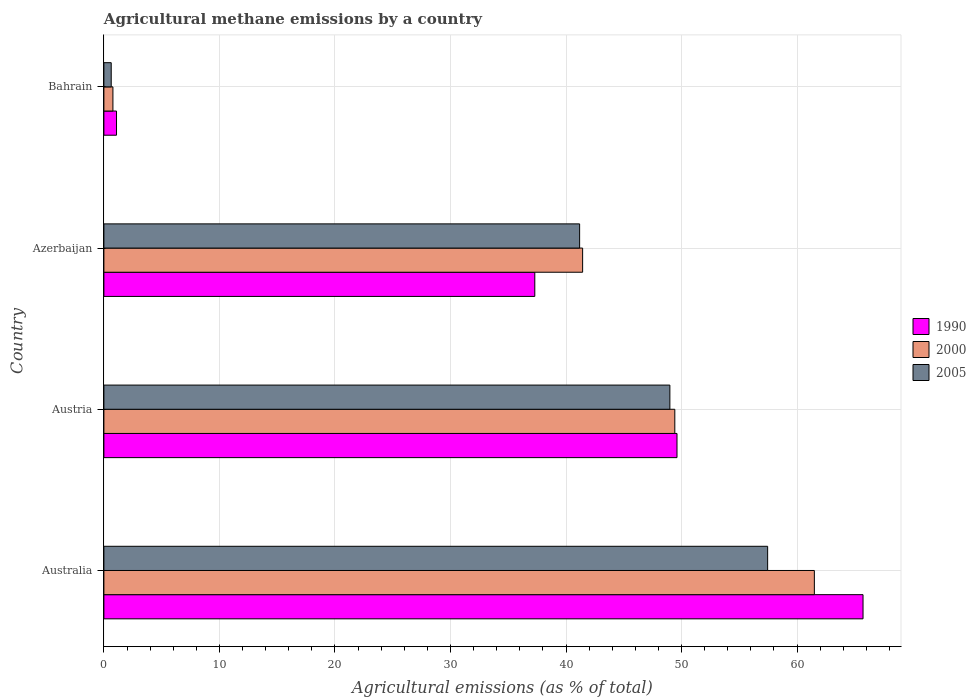How many different coloured bars are there?
Offer a terse response. 3. How many bars are there on the 4th tick from the top?
Your answer should be compact. 3. How many bars are there on the 1st tick from the bottom?
Give a very brief answer. 3. What is the label of the 2nd group of bars from the top?
Ensure brevity in your answer.  Azerbaijan. What is the amount of agricultural methane emitted in 2000 in Australia?
Offer a very short reply. 61.5. Across all countries, what is the maximum amount of agricultural methane emitted in 1990?
Offer a terse response. 65.71. Across all countries, what is the minimum amount of agricultural methane emitted in 1990?
Your answer should be very brief. 1.09. In which country was the amount of agricultural methane emitted in 1990 maximum?
Provide a short and direct response. Australia. In which country was the amount of agricultural methane emitted in 2000 minimum?
Give a very brief answer. Bahrain. What is the total amount of agricultural methane emitted in 2000 in the graph?
Give a very brief answer. 153.13. What is the difference between the amount of agricultural methane emitted in 2000 in Austria and that in Azerbaijan?
Your response must be concise. 7.98. What is the difference between the amount of agricultural methane emitted in 2000 in Bahrain and the amount of agricultural methane emitted in 2005 in Australia?
Your response must be concise. -56.67. What is the average amount of agricultural methane emitted in 2005 per country?
Offer a very short reply. 37.06. What is the difference between the amount of agricultural methane emitted in 2000 and amount of agricultural methane emitted in 1990 in Australia?
Ensure brevity in your answer.  -4.21. In how many countries, is the amount of agricultural methane emitted in 2005 greater than 26 %?
Offer a very short reply. 3. What is the ratio of the amount of agricultural methane emitted in 2000 in Austria to that in Azerbaijan?
Provide a short and direct response. 1.19. Is the difference between the amount of agricultural methane emitted in 2000 in Australia and Azerbaijan greater than the difference between the amount of agricultural methane emitted in 1990 in Australia and Azerbaijan?
Give a very brief answer. No. What is the difference between the highest and the second highest amount of agricultural methane emitted in 2000?
Your response must be concise. 12.08. What is the difference between the highest and the lowest amount of agricultural methane emitted in 1990?
Offer a terse response. 64.62. In how many countries, is the amount of agricultural methane emitted in 1990 greater than the average amount of agricultural methane emitted in 1990 taken over all countries?
Your answer should be very brief. 2. What does the 3rd bar from the bottom in Azerbaijan represents?
Make the answer very short. 2005. How many bars are there?
Offer a terse response. 12. Are all the bars in the graph horizontal?
Your answer should be very brief. Yes. What is the difference between two consecutive major ticks on the X-axis?
Offer a very short reply. 10. Are the values on the major ticks of X-axis written in scientific E-notation?
Provide a short and direct response. No. How many legend labels are there?
Ensure brevity in your answer.  3. How are the legend labels stacked?
Provide a short and direct response. Vertical. What is the title of the graph?
Offer a very short reply. Agricultural methane emissions by a country. What is the label or title of the X-axis?
Provide a short and direct response. Agricultural emissions (as % of total). What is the label or title of the Y-axis?
Give a very brief answer. Country. What is the Agricultural emissions (as % of total) of 1990 in Australia?
Give a very brief answer. 65.71. What is the Agricultural emissions (as % of total) in 2000 in Australia?
Provide a short and direct response. 61.5. What is the Agricultural emissions (as % of total) of 2005 in Australia?
Your answer should be compact. 57.45. What is the Agricultural emissions (as % of total) in 1990 in Austria?
Offer a terse response. 49.61. What is the Agricultural emissions (as % of total) in 2000 in Austria?
Your answer should be compact. 49.42. What is the Agricultural emissions (as % of total) in 2005 in Austria?
Give a very brief answer. 48.99. What is the Agricultural emissions (as % of total) in 1990 in Azerbaijan?
Your response must be concise. 37.3. What is the Agricultural emissions (as % of total) in 2000 in Azerbaijan?
Keep it short and to the point. 41.44. What is the Agricultural emissions (as % of total) of 2005 in Azerbaijan?
Offer a terse response. 41.18. What is the Agricultural emissions (as % of total) in 1990 in Bahrain?
Ensure brevity in your answer.  1.09. What is the Agricultural emissions (as % of total) of 2000 in Bahrain?
Give a very brief answer. 0.78. What is the Agricultural emissions (as % of total) of 2005 in Bahrain?
Your answer should be compact. 0.63. Across all countries, what is the maximum Agricultural emissions (as % of total) of 1990?
Provide a succinct answer. 65.71. Across all countries, what is the maximum Agricultural emissions (as % of total) of 2000?
Provide a succinct answer. 61.5. Across all countries, what is the maximum Agricultural emissions (as % of total) of 2005?
Make the answer very short. 57.45. Across all countries, what is the minimum Agricultural emissions (as % of total) of 1990?
Ensure brevity in your answer.  1.09. Across all countries, what is the minimum Agricultural emissions (as % of total) in 2000?
Your answer should be very brief. 0.78. Across all countries, what is the minimum Agricultural emissions (as % of total) of 2005?
Give a very brief answer. 0.63. What is the total Agricultural emissions (as % of total) of 1990 in the graph?
Make the answer very short. 153.71. What is the total Agricultural emissions (as % of total) in 2000 in the graph?
Provide a short and direct response. 153.13. What is the total Agricultural emissions (as % of total) in 2005 in the graph?
Provide a succinct answer. 148.25. What is the difference between the Agricultural emissions (as % of total) in 1990 in Australia and that in Austria?
Provide a short and direct response. 16.1. What is the difference between the Agricultural emissions (as % of total) in 2000 in Australia and that in Austria?
Ensure brevity in your answer.  12.08. What is the difference between the Agricultural emissions (as % of total) of 2005 in Australia and that in Austria?
Your answer should be very brief. 8.46. What is the difference between the Agricultural emissions (as % of total) in 1990 in Australia and that in Azerbaijan?
Keep it short and to the point. 28.41. What is the difference between the Agricultural emissions (as % of total) in 2000 in Australia and that in Azerbaijan?
Offer a very short reply. 20.06. What is the difference between the Agricultural emissions (as % of total) of 2005 in Australia and that in Azerbaijan?
Offer a terse response. 16.27. What is the difference between the Agricultural emissions (as % of total) in 1990 in Australia and that in Bahrain?
Offer a terse response. 64.62. What is the difference between the Agricultural emissions (as % of total) in 2000 in Australia and that in Bahrain?
Provide a short and direct response. 60.72. What is the difference between the Agricultural emissions (as % of total) in 2005 in Australia and that in Bahrain?
Your answer should be very brief. 56.82. What is the difference between the Agricultural emissions (as % of total) of 1990 in Austria and that in Azerbaijan?
Provide a succinct answer. 12.31. What is the difference between the Agricultural emissions (as % of total) in 2000 in Austria and that in Azerbaijan?
Give a very brief answer. 7.98. What is the difference between the Agricultural emissions (as % of total) of 2005 in Austria and that in Azerbaijan?
Give a very brief answer. 7.81. What is the difference between the Agricultural emissions (as % of total) in 1990 in Austria and that in Bahrain?
Your response must be concise. 48.51. What is the difference between the Agricultural emissions (as % of total) in 2000 in Austria and that in Bahrain?
Your response must be concise. 48.64. What is the difference between the Agricultural emissions (as % of total) in 2005 in Austria and that in Bahrain?
Your answer should be very brief. 48.36. What is the difference between the Agricultural emissions (as % of total) of 1990 in Azerbaijan and that in Bahrain?
Make the answer very short. 36.21. What is the difference between the Agricultural emissions (as % of total) of 2000 in Azerbaijan and that in Bahrain?
Provide a short and direct response. 40.66. What is the difference between the Agricultural emissions (as % of total) in 2005 in Azerbaijan and that in Bahrain?
Your response must be concise. 40.54. What is the difference between the Agricultural emissions (as % of total) of 1990 in Australia and the Agricultural emissions (as % of total) of 2000 in Austria?
Make the answer very short. 16.29. What is the difference between the Agricultural emissions (as % of total) in 1990 in Australia and the Agricultural emissions (as % of total) in 2005 in Austria?
Your answer should be very brief. 16.72. What is the difference between the Agricultural emissions (as % of total) of 2000 in Australia and the Agricultural emissions (as % of total) of 2005 in Austria?
Your answer should be compact. 12.51. What is the difference between the Agricultural emissions (as % of total) of 1990 in Australia and the Agricultural emissions (as % of total) of 2000 in Azerbaijan?
Offer a terse response. 24.27. What is the difference between the Agricultural emissions (as % of total) in 1990 in Australia and the Agricultural emissions (as % of total) in 2005 in Azerbaijan?
Your answer should be very brief. 24.53. What is the difference between the Agricultural emissions (as % of total) of 2000 in Australia and the Agricultural emissions (as % of total) of 2005 in Azerbaijan?
Ensure brevity in your answer.  20.32. What is the difference between the Agricultural emissions (as % of total) in 1990 in Australia and the Agricultural emissions (as % of total) in 2000 in Bahrain?
Give a very brief answer. 64.93. What is the difference between the Agricultural emissions (as % of total) in 1990 in Australia and the Agricultural emissions (as % of total) in 2005 in Bahrain?
Provide a succinct answer. 65.08. What is the difference between the Agricultural emissions (as % of total) of 2000 in Australia and the Agricultural emissions (as % of total) of 2005 in Bahrain?
Your answer should be compact. 60.86. What is the difference between the Agricultural emissions (as % of total) in 1990 in Austria and the Agricultural emissions (as % of total) in 2000 in Azerbaijan?
Ensure brevity in your answer.  8.17. What is the difference between the Agricultural emissions (as % of total) in 1990 in Austria and the Agricultural emissions (as % of total) in 2005 in Azerbaijan?
Ensure brevity in your answer.  8.43. What is the difference between the Agricultural emissions (as % of total) in 2000 in Austria and the Agricultural emissions (as % of total) in 2005 in Azerbaijan?
Provide a succinct answer. 8.24. What is the difference between the Agricultural emissions (as % of total) of 1990 in Austria and the Agricultural emissions (as % of total) of 2000 in Bahrain?
Your response must be concise. 48.82. What is the difference between the Agricultural emissions (as % of total) of 1990 in Austria and the Agricultural emissions (as % of total) of 2005 in Bahrain?
Give a very brief answer. 48.97. What is the difference between the Agricultural emissions (as % of total) of 2000 in Austria and the Agricultural emissions (as % of total) of 2005 in Bahrain?
Provide a short and direct response. 48.78. What is the difference between the Agricultural emissions (as % of total) in 1990 in Azerbaijan and the Agricultural emissions (as % of total) in 2000 in Bahrain?
Make the answer very short. 36.52. What is the difference between the Agricultural emissions (as % of total) of 1990 in Azerbaijan and the Agricultural emissions (as % of total) of 2005 in Bahrain?
Give a very brief answer. 36.66. What is the difference between the Agricultural emissions (as % of total) of 2000 in Azerbaijan and the Agricultural emissions (as % of total) of 2005 in Bahrain?
Your answer should be very brief. 40.8. What is the average Agricultural emissions (as % of total) in 1990 per country?
Your response must be concise. 38.43. What is the average Agricultural emissions (as % of total) of 2000 per country?
Your answer should be compact. 38.28. What is the average Agricultural emissions (as % of total) of 2005 per country?
Make the answer very short. 37.06. What is the difference between the Agricultural emissions (as % of total) in 1990 and Agricultural emissions (as % of total) in 2000 in Australia?
Make the answer very short. 4.21. What is the difference between the Agricultural emissions (as % of total) of 1990 and Agricultural emissions (as % of total) of 2005 in Australia?
Offer a terse response. 8.26. What is the difference between the Agricultural emissions (as % of total) of 2000 and Agricultural emissions (as % of total) of 2005 in Australia?
Offer a terse response. 4.04. What is the difference between the Agricultural emissions (as % of total) of 1990 and Agricultural emissions (as % of total) of 2000 in Austria?
Make the answer very short. 0.19. What is the difference between the Agricultural emissions (as % of total) in 1990 and Agricultural emissions (as % of total) in 2005 in Austria?
Your answer should be very brief. 0.62. What is the difference between the Agricultural emissions (as % of total) in 2000 and Agricultural emissions (as % of total) in 2005 in Austria?
Your response must be concise. 0.43. What is the difference between the Agricultural emissions (as % of total) of 1990 and Agricultural emissions (as % of total) of 2000 in Azerbaijan?
Make the answer very short. -4.14. What is the difference between the Agricultural emissions (as % of total) in 1990 and Agricultural emissions (as % of total) in 2005 in Azerbaijan?
Provide a short and direct response. -3.88. What is the difference between the Agricultural emissions (as % of total) in 2000 and Agricultural emissions (as % of total) in 2005 in Azerbaijan?
Your answer should be compact. 0.26. What is the difference between the Agricultural emissions (as % of total) in 1990 and Agricultural emissions (as % of total) in 2000 in Bahrain?
Provide a succinct answer. 0.31. What is the difference between the Agricultural emissions (as % of total) of 1990 and Agricultural emissions (as % of total) of 2005 in Bahrain?
Your answer should be very brief. 0.46. What is the difference between the Agricultural emissions (as % of total) in 2000 and Agricultural emissions (as % of total) in 2005 in Bahrain?
Offer a terse response. 0.15. What is the ratio of the Agricultural emissions (as % of total) of 1990 in Australia to that in Austria?
Your answer should be compact. 1.32. What is the ratio of the Agricultural emissions (as % of total) in 2000 in Australia to that in Austria?
Offer a very short reply. 1.24. What is the ratio of the Agricultural emissions (as % of total) in 2005 in Australia to that in Austria?
Provide a short and direct response. 1.17. What is the ratio of the Agricultural emissions (as % of total) of 1990 in Australia to that in Azerbaijan?
Your answer should be compact. 1.76. What is the ratio of the Agricultural emissions (as % of total) in 2000 in Australia to that in Azerbaijan?
Your answer should be compact. 1.48. What is the ratio of the Agricultural emissions (as % of total) in 2005 in Australia to that in Azerbaijan?
Ensure brevity in your answer.  1.4. What is the ratio of the Agricultural emissions (as % of total) of 1990 in Australia to that in Bahrain?
Offer a terse response. 60.17. What is the ratio of the Agricultural emissions (as % of total) in 2000 in Australia to that in Bahrain?
Your answer should be compact. 78.66. What is the ratio of the Agricultural emissions (as % of total) in 2005 in Australia to that in Bahrain?
Offer a terse response. 90.68. What is the ratio of the Agricultural emissions (as % of total) of 1990 in Austria to that in Azerbaijan?
Provide a succinct answer. 1.33. What is the ratio of the Agricultural emissions (as % of total) of 2000 in Austria to that in Azerbaijan?
Make the answer very short. 1.19. What is the ratio of the Agricultural emissions (as % of total) in 2005 in Austria to that in Azerbaijan?
Ensure brevity in your answer.  1.19. What is the ratio of the Agricultural emissions (as % of total) in 1990 in Austria to that in Bahrain?
Your answer should be compact. 45.42. What is the ratio of the Agricultural emissions (as % of total) in 2000 in Austria to that in Bahrain?
Offer a terse response. 63.21. What is the ratio of the Agricultural emissions (as % of total) in 2005 in Austria to that in Bahrain?
Make the answer very short. 77.32. What is the ratio of the Agricultural emissions (as % of total) in 1990 in Azerbaijan to that in Bahrain?
Provide a succinct answer. 34.15. What is the ratio of the Agricultural emissions (as % of total) of 2000 in Azerbaijan to that in Bahrain?
Your response must be concise. 53. What is the ratio of the Agricultural emissions (as % of total) of 2005 in Azerbaijan to that in Bahrain?
Provide a short and direct response. 64.99. What is the difference between the highest and the second highest Agricultural emissions (as % of total) of 1990?
Provide a short and direct response. 16.1. What is the difference between the highest and the second highest Agricultural emissions (as % of total) in 2000?
Make the answer very short. 12.08. What is the difference between the highest and the second highest Agricultural emissions (as % of total) in 2005?
Your answer should be very brief. 8.46. What is the difference between the highest and the lowest Agricultural emissions (as % of total) of 1990?
Keep it short and to the point. 64.62. What is the difference between the highest and the lowest Agricultural emissions (as % of total) in 2000?
Ensure brevity in your answer.  60.72. What is the difference between the highest and the lowest Agricultural emissions (as % of total) in 2005?
Make the answer very short. 56.82. 